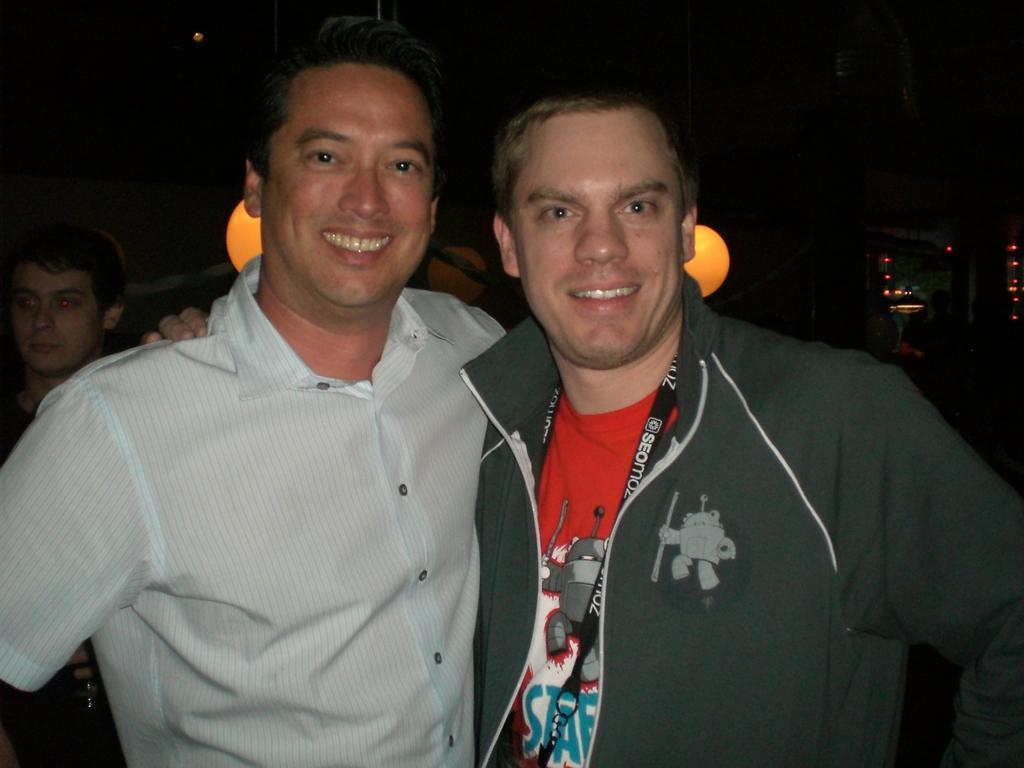Describe this image in one or two sentences. In this image we can see two persons. One person is wearing a tag. In the background there is another person. Also we can see lights. 